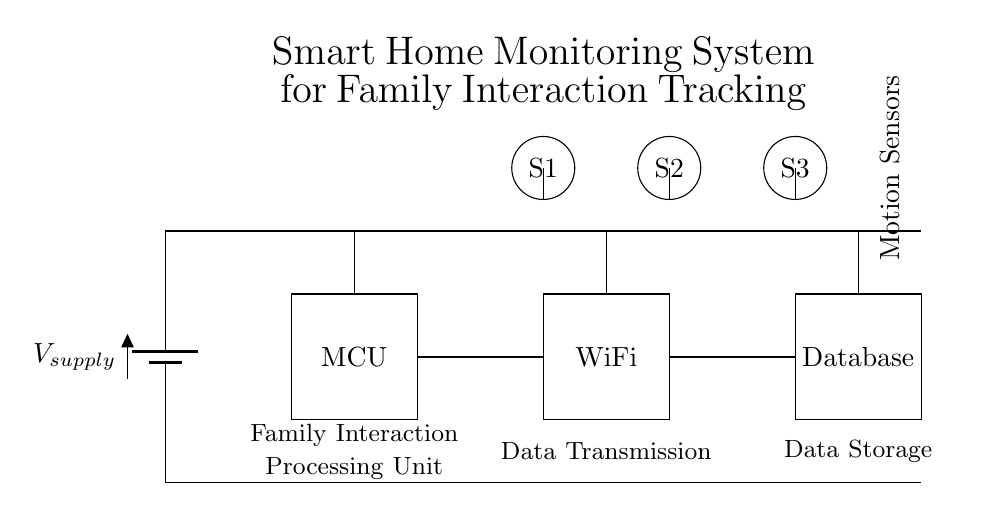What is the main component for processing data in this circuit? The main component for processing data is the microcontroller, indicated by the labeled rectangle in the diagram.
Answer: Microcontroller How many motion sensors are present in the circuit? The circuit diagram shows three motion sensors, labeled as S1, S2, and S3. They are represented by circles at the top of the diagram.
Answer: Three What does the WiFi module connect to in this circuit? The WiFi module connects to the microcontroller on one side and the database on the other side. This is shown by the lines that link the WiFi rectangle to the MCU and Database.
Answer: Microcontroller and Database What is the purpose of the database in this system? The database is used for data storage, as indicated by the label on the rectangle and its position receiving data from the WiFi module.
Answer: Data storage What type of data does this smart home system monitor? The system monitors family interactions, as stated in the title of the circuit diagram and the context of the sensors used.
Answer: Family interactions What is the power source for the circuit? The power source is a battery labeled as V_supply, which provides the necessary voltage to operate the components in the circuit.
Answer: Battery How is data transmitted in the circuit? Data is transmitted via the WiFi module, which connects the microcontroller to the database, facilitating the transfer of information gathered from the motion sensors.
Answer: WiFi module 